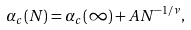Convert formula to latex. <formula><loc_0><loc_0><loc_500><loc_500>\alpha _ { c } ( N ) = \alpha _ { c } ( \infty ) + A N ^ { - 1 / \nu } ,</formula> 